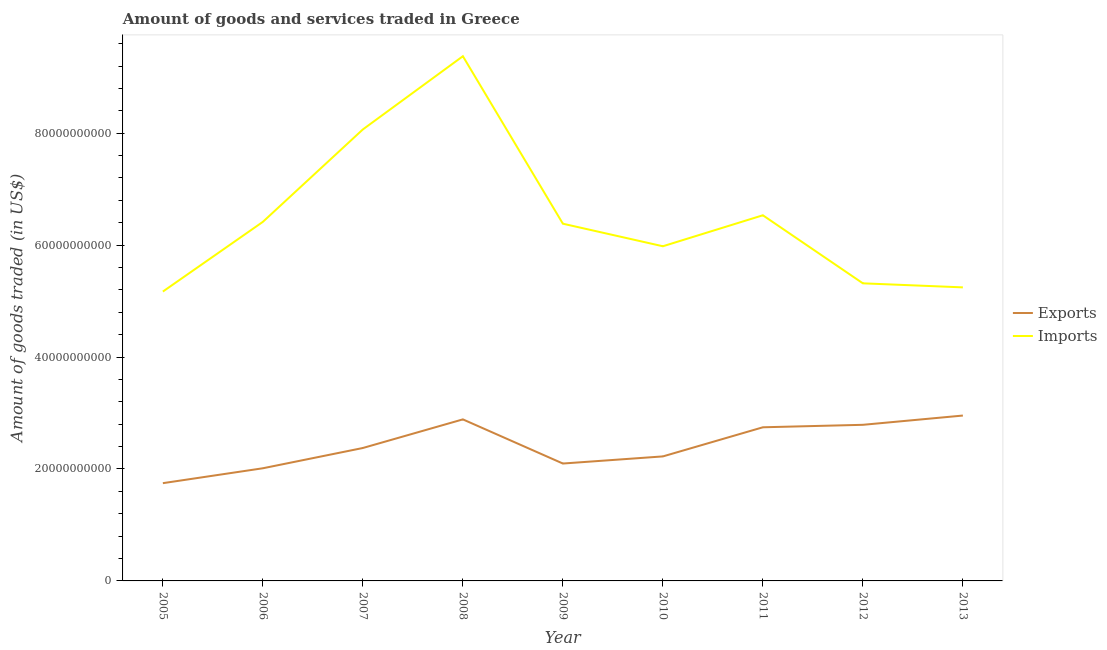How many different coloured lines are there?
Your response must be concise. 2. Does the line corresponding to amount of goods exported intersect with the line corresponding to amount of goods imported?
Provide a short and direct response. No. What is the amount of goods exported in 2006?
Keep it short and to the point. 2.01e+1. Across all years, what is the maximum amount of goods imported?
Provide a succinct answer. 9.38e+1. Across all years, what is the minimum amount of goods imported?
Provide a short and direct response. 5.17e+1. In which year was the amount of goods imported maximum?
Your answer should be compact. 2008. In which year was the amount of goods imported minimum?
Offer a terse response. 2005. What is the total amount of goods exported in the graph?
Your answer should be compact. 2.18e+11. What is the difference between the amount of goods imported in 2009 and that in 2010?
Provide a short and direct response. 4.03e+09. What is the difference between the amount of goods imported in 2006 and the amount of goods exported in 2005?
Make the answer very short. 4.67e+1. What is the average amount of goods exported per year?
Your answer should be very brief. 2.43e+1. In the year 2011, what is the difference between the amount of goods imported and amount of goods exported?
Your answer should be very brief. 3.79e+1. In how many years, is the amount of goods imported greater than 60000000000 US$?
Your answer should be very brief. 5. What is the ratio of the amount of goods imported in 2006 to that in 2009?
Your answer should be compact. 1.01. Is the amount of goods exported in 2011 less than that in 2012?
Give a very brief answer. Yes. What is the difference between the highest and the second highest amount of goods imported?
Your answer should be very brief. 1.31e+1. What is the difference between the highest and the lowest amount of goods imported?
Provide a succinct answer. 4.21e+1. In how many years, is the amount of goods imported greater than the average amount of goods imported taken over all years?
Offer a terse response. 3. Is the sum of the amount of goods imported in 2005 and 2010 greater than the maximum amount of goods exported across all years?
Ensure brevity in your answer.  Yes. Is the amount of goods imported strictly greater than the amount of goods exported over the years?
Offer a terse response. Yes. Is the amount of goods exported strictly less than the amount of goods imported over the years?
Your answer should be compact. Yes. How many lines are there?
Provide a succinct answer. 2. What is the difference between two consecutive major ticks on the Y-axis?
Offer a very short reply. 2.00e+1. Does the graph contain any zero values?
Make the answer very short. No. Does the graph contain grids?
Offer a very short reply. No. What is the title of the graph?
Provide a short and direct response. Amount of goods and services traded in Greece. What is the label or title of the Y-axis?
Provide a succinct answer. Amount of goods traded (in US$). What is the Amount of goods traded (in US$) in Exports in 2005?
Provide a succinct answer. 1.75e+1. What is the Amount of goods traded (in US$) in Imports in 2005?
Offer a terse response. 5.17e+1. What is the Amount of goods traded (in US$) of Exports in 2006?
Keep it short and to the point. 2.01e+1. What is the Amount of goods traded (in US$) in Imports in 2006?
Ensure brevity in your answer.  6.42e+1. What is the Amount of goods traded (in US$) of Exports in 2007?
Your answer should be compact. 2.38e+1. What is the Amount of goods traded (in US$) of Imports in 2007?
Offer a very short reply. 8.07e+1. What is the Amount of goods traded (in US$) in Exports in 2008?
Your answer should be very brief. 2.89e+1. What is the Amount of goods traded (in US$) in Imports in 2008?
Ensure brevity in your answer.  9.38e+1. What is the Amount of goods traded (in US$) in Exports in 2009?
Keep it short and to the point. 2.10e+1. What is the Amount of goods traded (in US$) in Imports in 2009?
Your response must be concise. 6.38e+1. What is the Amount of goods traded (in US$) of Exports in 2010?
Make the answer very short. 2.22e+1. What is the Amount of goods traded (in US$) of Imports in 2010?
Your answer should be compact. 5.98e+1. What is the Amount of goods traded (in US$) of Exports in 2011?
Provide a short and direct response. 2.75e+1. What is the Amount of goods traded (in US$) of Imports in 2011?
Give a very brief answer. 6.53e+1. What is the Amount of goods traded (in US$) of Exports in 2012?
Your answer should be very brief. 2.79e+1. What is the Amount of goods traded (in US$) in Imports in 2012?
Your response must be concise. 5.32e+1. What is the Amount of goods traded (in US$) in Exports in 2013?
Provide a succinct answer. 2.96e+1. What is the Amount of goods traded (in US$) in Imports in 2013?
Ensure brevity in your answer.  5.25e+1. Across all years, what is the maximum Amount of goods traded (in US$) of Exports?
Make the answer very short. 2.96e+1. Across all years, what is the maximum Amount of goods traded (in US$) in Imports?
Offer a very short reply. 9.38e+1. Across all years, what is the minimum Amount of goods traded (in US$) of Exports?
Your response must be concise. 1.75e+1. Across all years, what is the minimum Amount of goods traded (in US$) of Imports?
Make the answer very short. 5.17e+1. What is the total Amount of goods traded (in US$) of Exports in the graph?
Make the answer very short. 2.18e+11. What is the total Amount of goods traded (in US$) of Imports in the graph?
Make the answer very short. 5.85e+11. What is the difference between the Amount of goods traded (in US$) of Exports in 2005 and that in 2006?
Ensure brevity in your answer.  -2.66e+09. What is the difference between the Amount of goods traded (in US$) in Imports in 2005 and that in 2006?
Make the answer very short. -1.25e+1. What is the difference between the Amount of goods traded (in US$) of Exports in 2005 and that in 2007?
Make the answer very short. -6.28e+09. What is the difference between the Amount of goods traded (in US$) of Imports in 2005 and that in 2007?
Your answer should be very brief. -2.90e+1. What is the difference between the Amount of goods traded (in US$) of Exports in 2005 and that in 2008?
Give a very brief answer. -1.14e+1. What is the difference between the Amount of goods traded (in US$) in Imports in 2005 and that in 2008?
Your answer should be very brief. -4.21e+1. What is the difference between the Amount of goods traded (in US$) of Exports in 2005 and that in 2009?
Give a very brief answer. -3.51e+09. What is the difference between the Amount of goods traded (in US$) of Imports in 2005 and that in 2009?
Your answer should be very brief. -1.21e+1. What is the difference between the Amount of goods traded (in US$) in Exports in 2005 and that in 2010?
Ensure brevity in your answer.  -4.78e+09. What is the difference between the Amount of goods traded (in US$) in Imports in 2005 and that in 2010?
Offer a terse response. -8.10e+09. What is the difference between the Amount of goods traded (in US$) in Exports in 2005 and that in 2011?
Make the answer very short. -9.98e+09. What is the difference between the Amount of goods traded (in US$) of Imports in 2005 and that in 2011?
Your answer should be compact. -1.36e+1. What is the difference between the Amount of goods traded (in US$) in Exports in 2005 and that in 2012?
Your response must be concise. -1.04e+1. What is the difference between the Amount of goods traded (in US$) in Imports in 2005 and that in 2012?
Provide a short and direct response. -1.47e+09. What is the difference between the Amount of goods traded (in US$) in Exports in 2005 and that in 2013?
Keep it short and to the point. -1.21e+1. What is the difference between the Amount of goods traded (in US$) of Imports in 2005 and that in 2013?
Your answer should be compact. -7.50e+08. What is the difference between the Amount of goods traded (in US$) of Exports in 2006 and that in 2007?
Keep it short and to the point. -3.62e+09. What is the difference between the Amount of goods traded (in US$) in Imports in 2006 and that in 2007?
Make the answer very short. -1.65e+1. What is the difference between the Amount of goods traded (in US$) in Exports in 2006 and that in 2008?
Make the answer very short. -8.74e+09. What is the difference between the Amount of goods traded (in US$) of Imports in 2006 and that in 2008?
Provide a short and direct response. -2.96e+1. What is the difference between the Amount of goods traded (in US$) of Exports in 2006 and that in 2009?
Make the answer very short. -8.46e+08. What is the difference between the Amount of goods traded (in US$) in Imports in 2006 and that in 2009?
Offer a terse response. 3.30e+08. What is the difference between the Amount of goods traded (in US$) of Exports in 2006 and that in 2010?
Keep it short and to the point. -2.12e+09. What is the difference between the Amount of goods traded (in US$) in Imports in 2006 and that in 2010?
Your answer should be very brief. 4.36e+09. What is the difference between the Amount of goods traded (in US$) in Exports in 2006 and that in 2011?
Make the answer very short. -7.32e+09. What is the difference between the Amount of goods traded (in US$) of Imports in 2006 and that in 2011?
Offer a terse response. -1.17e+09. What is the difference between the Amount of goods traded (in US$) of Exports in 2006 and that in 2012?
Your response must be concise. -7.76e+09. What is the difference between the Amount of goods traded (in US$) in Imports in 2006 and that in 2012?
Your response must be concise. 1.10e+1. What is the difference between the Amount of goods traded (in US$) of Exports in 2006 and that in 2013?
Keep it short and to the point. -9.42e+09. What is the difference between the Amount of goods traded (in US$) of Imports in 2006 and that in 2013?
Offer a terse response. 1.17e+1. What is the difference between the Amount of goods traded (in US$) in Exports in 2007 and that in 2008?
Offer a terse response. -5.11e+09. What is the difference between the Amount of goods traded (in US$) of Imports in 2007 and that in 2008?
Provide a short and direct response. -1.31e+1. What is the difference between the Amount of goods traded (in US$) of Exports in 2007 and that in 2009?
Ensure brevity in your answer.  2.78e+09. What is the difference between the Amount of goods traded (in US$) in Imports in 2007 and that in 2009?
Your answer should be compact. 1.68e+1. What is the difference between the Amount of goods traded (in US$) in Exports in 2007 and that in 2010?
Ensure brevity in your answer.  1.50e+09. What is the difference between the Amount of goods traded (in US$) in Imports in 2007 and that in 2010?
Make the answer very short. 2.09e+1. What is the difference between the Amount of goods traded (in US$) in Exports in 2007 and that in 2011?
Your response must be concise. -3.70e+09. What is the difference between the Amount of goods traded (in US$) in Imports in 2007 and that in 2011?
Ensure brevity in your answer.  1.53e+1. What is the difference between the Amount of goods traded (in US$) of Exports in 2007 and that in 2012?
Make the answer very short. -4.14e+09. What is the difference between the Amount of goods traded (in US$) of Imports in 2007 and that in 2012?
Make the answer very short. 2.75e+1. What is the difference between the Amount of goods traded (in US$) in Exports in 2007 and that in 2013?
Keep it short and to the point. -5.80e+09. What is the difference between the Amount of goods traded (in US$) in Imports in 2007 and that in 2013?
Offer a very short reply. 2.82e+1. What is the difference between the Amount of goods traded (in US$) of Exports in 2008 and that in 2009?
Provide a succinct answer. 7.89e+09. What is the difference between the Amount of goods traded (in US$) in Imports in 2008 and that in 2009?
Your answer should be compact. 2.99e+1. What is the difference between the Amount of goods traded (in US$) in Exports in 2008 and that in 2010?
Give a very brief answer. 6.62e+09. What is the difference between the Amount of goods traded (in US$) in Imports in 2008 and that in 2010?
Your answer should be compact. 3.40e+1. What is the difference between the Amount of goods traded (in US$) in Exports in 2008 and that in 2011?
Offer a very short reply. 1.41e+09. What is the difference between the Amount of goods traded (in US$) of Imports in 2008 and that in 2011?
Provide a short and direct response. 2.84e+1. What is the difference between the Amount of goods traded (in US$) of Exports in 2008 and that in 2012?
Provide a short and direct response. 9.71e+08. What is the difference between the Amount of goods traded (in US$) of Imports in 2008 and that in 2012?
Give a very brief answer. 4.06e+1. What is the difference between the Amount of goods traded (in US$) of Exports in 2008 and that in 2013?
Provide a short and direct response. -6.85e+08. What is the difference between the Amount of goods traded (in US$) of Imports in 2008 and that in 2013?
Make the answer very short. 4.13e+1. What is the difference between the Amount of goods traded (in US$) of Exports in 2009 and that in 2010?
Your answer should be compact. -1.27e+09. What is the difference between the Amount of goods traded (in US$) in Imports in 2009 and that in 2010?
Your answer should be very brief. 4.03e+09. What is the difference between the Amount of goods traded (in US$) in Exports in 2009 and that in 2011?
Provide a succinct answer. -6.48e+09. What is the difference between the Amount of goods traded (in US$) in Imports in 2009 and that in 2011?
Keep it short and to the point. -1.50e+09. What is the difference between the Amount of goods traded (in US$) of Exports in 2009 and that in 2012?
Offer a terse response. -6.92e+09. What is the difference between the Amount of goods traded (in US$) of Imports in 2009 and that in 2012?
Your answer should be compact. 1.07e+1. What is the difference between the Amount of goods traded (in US$) of Exports in 2009 and that in 2013?
Your answer should be compact. -8.57e+09. What is the difference between the Amount of goods traded (in US$) in Imports in 2009 and that in 2013?
Make the answer very short. 1.14e+1. What is the difference between the Amount of goods traded (in US$) of Exports in 2010 and that in 2011?
Offer a very short reply. -5.20e+09. What is the difference between the Amount of goods traded (in US$) in Imports in 2010 and that in 2011?
Give a very brief answer. -5.54e+09. What is the difference between the Amount of goods traded (in US$) in Exports in 2010 and that in 2012?
Your answer should be very brief. -5.65e+09. What is the difference between the Amount of goods traded (in US$) in Imports in 2010 and that in 2012?
Your response must be concise. 6.63e+09. What is the difference between the Amount of goods traded (in US$) of Exports in 2010 and that in 2013?
Make the answer very short. -7.30e+09. What is the difference between the Amount of goods traded (in US$) of Imports in 2010 and that in 2013?
Your answer should be very brief. 7.35e+09. What is the difference between the Amount of goods traded (in US$) of Exports in 2011 and that in 2012?
Make the answer very short. -4.41e+08. What is the difference between the Amount of goods traded (in US$) in Imports in 2011 and that in 2012?
Keep it short and to the point. 1.22e+1. What is the difference between the Amount of goods traded (in US$) in Exports in 2011 and that in 2013?
Offer a terse response. -2.10e+09. What is the difference between the Amount of goods traded (in US$) of Imports in 2011 and that in 2013?
Offer a very short reply. 1.29e+1. What is the difference between the Amount of goods traded (in US$) in Exports in 2012 and that in 2013?
Keep it short and to the point. -1.66e+09. What is the difference between the Amount of goods traded (in US$) in Imports in 2012 and that in 2013?
Provide a succinct answer. 7.21e+08. What is the difference between the Amount of goods traded (in US$) of Exports in 2005 and the Amount of goods traded (in US$) of Imports in 2006?
Your answer should be very brief. -4.67e+1. What is the difference between the Amount of goods traded (in US$) in Exports in 2005 and the Amount of goods traded (in US$) in Imports in 2007?
Offer a very short reply. -6.32e+1. What is the difference between the Amount of goods traded (in US$) in Exports in 2005 and the Amount of goods traded (in US$) in Imports in 2008?
Keep it short and to the point. -7.63e+1. What is the difference between the Amount of goods traded (in US$) in Exports in 2005 and the Amount of goods traded (in US$) in Imports in 2009?
Keep it short and to the point. -4.64e+1. What is the difference between the Amount of goods traded (in US$) in Exports in 2005 and the Amount of goods traded (in US$) in Imports in 2010?
Keep it short and to the point. -4.23e+1. What is the difference between the Amount of goods traded (in US$) in Exports in 2005 and the Amount of goods traded (in US$) in Imports in 2011?
Offer a very short reply. -4.79e+1. What is the difference between the Amount of goods traded (in US$) of Exports in 2005 and the Amount of goods traded (in US$) of Imports in 2012?
Provide a succinct answer. -3.57e+1. What is the difference between the Amount of goods traded (in US$) of Exports in 2005 and the Amount of goods traded (in US$) of Imports in 2013?
Make the answer very short. -3.50e+1. What is the difference between the Amount of goods traded (in US$) in Exports in 2006 and the Amount of goods traded (in US$) in Imports in 2007?
Ensure brevity in your answer.  -6.05e+1. What is the difference between the Amount of goods traded (in US$) in Exports in 2006 and the Amount of goods traded (in US$) in Imports in 2008?
Give a very brief answer. -7.36e+1. What is the difference between the Amount of goods traded (in US$) of Exports in 2006 and the Amount of goods traded (in US$) of Imports in 2009?
Your response must be concise. -4.37e+1. What is the difference between the Amount of goods traded (in US$) in Exports in 2006 and the Amount of goods traded (in US$) in Imports in 2010?
Your answer should be very brief. -3.97e+1. What is the difference between the Amount of goods traded (in US$) of Exports in 2006 and the Amount of goods traded (in US$) of Imports in 2011?
Provide a succinct answer. -4.52e+1. What is the difference between the Amount of goods traded (in US$) in Exports in 2006 and the Amount of goods traded (in US$) in Imports in 2012?
Provide a short and direct response. -3.30e+1. What is the difference between the Amount of goods traded (in US$) in Exports in 2006 and the Amount of goods traded (in US$) in Imports in 2013?
Give a very brief answer. -3.23e+1. What is the difference between the Amount of goods traded (in US$) in Exports in 2007 and the Amount of goods traded (in US$) in Imports in 2008?
Your response must be concise. -7.00e+1. What is the difference between the Amount of goods traded (in US$) in Exports in 2007 and the Amount of goods traded (in US$) in Imports in 2009?
Make the answer very short. -4.01e+1. What is the difference between the Amount of goods traded (in US$) in Exports in 2007 and the Amount of goods traded (in US$) in Imports in 2010?
Provide a short and direct response. -3.60e+1. What is the difference between the Amount of goods traded (in US$) in Exports in 2007 and the Amount of goods traded (in US$) in Imports in 2011?
Your response must be concise. -4.16e+1. What is the difference between the Amount of goods traded (in US$) in Exports in 2007 and the Amount of goods traded (in US$) in Imports in 2012?
Give a very brief answer. -2.94e+1. What is the difference between the Amount of goods traded (in US$) in Exports in 2007 and the Amount of goods traded (in US$) in Imports in 2013?
Provide a short and direct response. -2.87e+1. What is the difference between the Amount of goods traded (in US$) of Exports in 2008 and the Amount of goods traded (in US$) of Imports in 2009?
Your response must be concise. -3.50e+1. What is the difference between the Amount of goods traded (in US$) in Exports in 2008 and the Amount of goods traded (in US$) in Imports in 2010?
Your answer should be very brief. -3.09e+1. What is the difference between the Amount of goods traded (in US$) in Exports in 2008 and the Amount of goods traded (in US$) in Imports in 2011?
Provide a short and direct response. -3.65e+1. What is the difference between the Amount of goods traded (in US$) in Exports in 2008 and the Amount of goods traded (in US$) in Imports in 2012?
Ensure brevity in your answer.  -2.43e+1. What is the difference between the Amount of goods traded (in US$) in Exports in 2008 and the Amount of goods traded (in US$) in Imports in 2013?
Your response must be concise. -2.36e+1. What is the difference between the Amount of goods traded (in US$) of Exports in 2009 and the Amount of goods traded (in US$) of Imports in 2010?
Your response must be concise. -3.88e+1. What is the difference between the Amount of goods traded (in US$) of Exports in 2009 and the Amount of goods traded (in US$) of Imports in 2011?
Your answer should be very brief. -4.44e+1. What is the difference between the Amount of goods traded (in US$) of Exports in 2009 and the Amount of goods traded (in US$) of Imports in 2012?
Make the answer very short. -3.22e+1. What is the difference between the Amount of goods traded (in US$) of Exports in 2009 and the Amount of goods traded (in US$) of Imports in 2013?
Keep it short and to the point. -3.15e+1. What is the difference between the Amount of goods traded (in US$) in Exports in 2010 and the Amount of goods traded (in US$) in Imports in 2011?
Your response must be concise. -4.31e+1. What is the difference between the Amount of goods traded (in US$) in Exports in 2010 and the Amount of goods traded (in US$) in Imports in 2012?
Keep it short and to the point. -3.09e+1. What is the difference between the Amount of goods traded (in US$) of Exports in 2010 and the Amount of goods traded (in US$) of Imports in 2013?
Make the answer very short. -3.02e+1. What is the difference between the Amount of goods traded (in US$) in Exports in 2011 and the Amount of goods traded (in US$) in Imports in 2012?
Your answer should be very brief. -2.57e+1. What is the difference between the Amount of goods traded (in US$) in Exports in 2011 and the Amount of goods traded (in US$) in Imports in 2013?
Your answer should be compact. -2.50e+1. What is the difference between the Amount of goods traded (in US$) of Exports in 2012 and the Amount of goods traded (in US$) of Imports in 2013?
Provide a succinct answer. -2.46e+1. What is the average Amount of goods traded (in US$) of Exports per year?
Your answer should be compact. 2.43e+1. What is the average Amount of goods traded (in US$) in Imports per year?
Your answer should be compact. 6.50e+1. In the year 2005, what is the difference between the Amount of goods traded (in US$) in Exports and Amount of goods traded (in US$) in Imports?
Give a very brief answer. -3.42e+1. In the year 2006, what is the difference between the Amount of goods traded (in US$) of Exports and Amount of goods traded (in US$) of Imports?
Offer a very short reply. -4.40e+1. In the year 2007, what is the difference between the Amount of goods traded (in US$) in Exports and Amount of goods traded (in US$) in Imports?
Provide a succinct answer. -5.69e+1. In the year 2008, what is the difference between the Amount of goods traded (in US$) of Exports and Amount of goods traded (in US$) of Imports?
Provide a short and direct response. -6.49e+1. In the year 2009, what is the difference between the Amount of goods traded (in US$) of Exports and Amount of goods traded (in US$) of Imports?
Make the answer very short. -4.29e+1. In the year 2010, what is the difference between the Amount of goods traded (in US$) of Exports and Amount of goods traded (in US$) of Imports?
Offer a very short reply. -3.76e+1. In the year 2011, what is the difference between the Amount of goods traded (in US$) of Exports and Amount of goods traded (in US$) of Imports?
Your answer should be compact. -3.79e+1. In the year 2012, what is the difference between the Amount of goods traded (in US$) of Exports and Amount of goods traded (in US$) of Imports?
Give a very brief answer. -2.53e+1. In the year 2013, what is the difference between the Amount of goods traded (in US$) of Exports and Amount of goods traded (in US$) of Imports?
Offer a terse response. -2.29e+1. What is the ratio of the Amount of goods traded (in US$) of Exports in 2005 to that in 2006?
Give a very brief answer. 0.87. What is the ratio of the Amount of goods traded (in US$) of Imports in 2005 to that in 2006?
Your response must be concise. 0.81. What is the ratio of the Amount of goods traded (in US$) of Exports in 2005 to that in 2007?
Give a very brief answer. 0.74. What is the ratio of the Amount of goods traded (in US$) in Imports in 2005 to that in 2007?
Provide a succinct answer. 0.64. What is the ratio of the Amount of goods traded (in US$) of Exports in 2005 to that in 2008?
Offer a terse response. 0.61. What is the ratio of the Amount of goods traded (in US$) of Imports in 2005 to that in 2008?
Give a very brief answer. 0.55. What is the ratio of the Amount of goods traded (in US$) in Exports in 2005 to that in 2009?
Offer a very short reply. 0.83. What is the ratio of the Amount of goods traded (in US$) in Imports in 2005 to that in 2009?
Ensure brevity in your answer.  0.81. What is the ratio of the Amount of goods traded (in US$) in Exports in 2005 to that in 2010?
Give a very brief answer. 0.79. What is the ratio of the Amount of goods traded (in US$) in Imports in 2005 to that in 2010?
Give a very brief answer. 0.86. What is the ratio of the Amount of goods traded (in US$) of Exports in 2005 to that in 2011?
Your answer should be compact. 0.64. What is the ratio of the Amount of goods traded (in US$) of Imports in 2005 to that in 2011?
Offer a terse response. 0.79. What is the ratio of the Amount of goods traded (in US$) of Exports in 2005 to that in 2012?
Give a very brief answer. 0.63. What is the ratio of the Amount of goods traded (in US$) in Imports in 2005 to that in 2012?
Offer a terse response. 0.97. What is the ratio of the Amount of goods traded (in US$) in Exports in 2005 to that in 2013?
Give a very brief answer. 0.59. What is the ratio of the Amount of goods traded (in US$) in Imports in 2005 to that in 2013?
Provide a short and direct response. 0.99. What is the ratio of the Amount of goods traded (in US$) of Exports in 2006 to that in 2007?
Give a very brief answer. 0.85. What is the ratio of the Amount of goods traded (in US$) of Imports in 2006 to that in 2007?
Your answer should be compact. 0.8. What is the ratio of the Amount of goods traded (in US$) in Exports in 2006 to that in 2008?
Offer a terse response. 0.7. What is the ratio of the Amount of goods traded (in US$) of Imports in 2006 to that in 2008?
Your answer should be compact. 0.68. What is the ratio of the Amount of goods traded (in US$) in Exports in 2006 to that in 2009?
Your answer should be very brief. 0.96. What is the ratio of the Amount of goods traded (in US$) of Imports in 2006 to that in 2009?
Keep it short and to the point. 1.01. What is the ratio of the Amount of goods traded (in US$) in Exports in 2006 to that in 2010?
Offer a very short reply. 0.9. What is the ratio of the Amount of goods traded (in US$) in Imports in 2006 to that in 2010?
Your answer should be compact. 1.07. What is the ratio of the Amount of goods traded (in US$) in Exports in 2006 to that in 2011?
Ensure brevity in your answer.  0.73. What is the ratio of the Amount of goods traded (in US$) of Exports in 2006 to that in 2012?
Keep it short and to the point. 0.72. What is the ratio of the Amount of goods traded (in US$) of Imports in 2006 to that in 2012?
Ensure brevity in your answer.  1.21. What is the ratio of the Amount of goods traded (in US$) of Exports in 2006 to that in 2013?
Provide a short and direct response. 0.68. What is the ratio of the Amount of goods traded (in US$) of Imports in 2006 to that in 2013?
Your answer should be compact. 1.22. What is the ratio of the Amount of goods traded (in US$) in Exports in 2007 to that in 2008?
Offer a terse response. 0.82. What is the ratio of the Amount of goods traded (in US$) of Imports in 2007 to that in 2008?
Provide a short and direct response. 0.86. What is the ratio of the Amount of goods traded (in US$) in Exports in 2007 to that in 2009?
Give a very brief answer. 1.13. What is the ratio of the Amount of goods traded (in US$) of Imports in 2007 to that in 2009?
Your response must be concise. 1.26. What is the ratio of the Amount of goods traded (in US$) in Exports in 2007 to that in 2010?
Offer a very short reply. 1.07. What is the ratio of the Amount of goods traded (in US$) in Imports in 2007 to that in 2010?
Offer a terse response. 1.35. What is the ratio of the Amount of goods traded (in US$) of Exports in 2007 to that in 2011?
Give a very brief answer. 0.87. What is the ratio of the Amount of goods traded (in US$) in Imports in 2007 to that in 2011?
Provide a succinct answer. 1.23. What is the ratio of the Amount of goods traded (in US$) of Exports in 2007 to that in 2012?
Your response must be concise. 0.85. What is the ratio of the Amount of goods traded (in US$) in Imports in 2007 to that in 2012?
Keep it short and to the point. 1.52. What is the ratio of the Amount of goods traded (in US$) in Exports in 2007 to that in 2013?
Offer a terse response. 0.8. What is the ratio of the Amount of goods traded (in US$) in Imports in 2007 to that in 2013?
Provide a succinct answer. 1.54. What is the ratio of the Amount of goods traded (in US$) in Exports in 2008 to that in 2009?
Give a very brief answer. 1.38. What is the ratio of the Amount of goods traded (in US$) of Imports in 2008 to that in 2009?
Provide a short and direct response. 1.47. What is the ratio of the Amount of goods traded (in US$) of Exports in 2008 to that in 2010?
Your answer should be very brief. 1.3. What is the ratio of the Amount of goods traded (in US$) in Imports in 2008 to that in 2010?
Keep it short and to the point. 1.57. What is the ratio of the Amount of goods traded (in US$) of Exports in 2008 to that in 2011?
Offer a terse response. 1.05. What is the ratio of the Amount of goods traded (in US$) of Imports in 2008 to that in 2011?
Offer a terse response. 1.44. What is the ratio of the Amount of goods traded (in US$) of Exports in 2008 to that in 2012?
Your response must be concise. 1.03. What is the ratio of the Amount of goods traded (in US$) of Imports in 2008 to that in 2012?
Provide a succinct answer. 1.76. What is the ratio of the Amount of goods traded (in US$) in Exports in 2008 to that in 2013?
Offer a very short reply. 0.98. What is the ratio of the Amount of goods traded (in US$) in Imports in 2008 to that in 2013?
Provide a short and direct response. 1.79. What is the ratio of the Amount of goods traded (in US$) of Exports in 2009 to that in 2010?
Offer a very short reply. 0.94. What is the ratio of the Amount of goods traded (in US$) in Imports in 2009 to that in 2010?
Your answer should be compact. 1.07. What is the ratio of the Amount of goods traded (in US$) of Exports in 2009 to that in 2011?
Give a very brief answer. 0.76. What is the ratio of the Amount of goods traded (in US$) in Imports in 2009 to that in 2011?
Provide a short and direct response. 0.98. What is the ratio of the Amount of goods traded (in US$) in Exports in 2009 to that in 2012?
Provide a short and direct response. 0.75. What is the ratio of the Amount of goods traded (in US$) in Imports in 2009 to that in 2012?
Make the answer very short. 1.2. What is the ratio of the Amount of goods traded (in US$) of Exports in 2009 to that in 2013?
Offer a terse response. 0.71. What is the ratio of the Amount of goods traded (in US$) in Imports in 2009 to that in 2013?
Offer a very short reply. 1.22. What is the ratio of the Amount of goods traded (in US$) of Exports in 2010 to that in 2011?
Your response must be concise. 0.81. What is the ratio of the Amount of goods traded (in US$) of Imports in 2010 to that in 2011?
Offer a terse response. 0.92. What is the ratio of the Amount of goods traded (in US$) of Exports in 2010 to that in 2012?
Provide a short and direct response. 0.8. What is the ratio of the Amount of goods traded (in US$) in Imports in 2010 to that in 2012?
Ensure brevity in your answer.  1.12. What is the ratio of the Amount of goods traded (in US$) of Exports in 2010 to that in 2013?
Keep it short and to the point. 0.75. What is the ratio of the Amount of goods traded (in US$) of Imports in 2010 to that in 2013?
Provide a succinct answer. 1.14. What is the ratio of the Amount of goods traded (in US$) of Exports in 2011 to that in 2012?
Your response must be concise. 0.98. What is the ratio of the Amount of goods traded (in US$) in Imports in 2011 to that in 2012?
Make the answer very short. 1.23. What is the ratio of the Amount of goods traded (in US$) in Exports in 2011 to that in 2013?
Your answer should be compact. 0.93. What is the ratio of the Amount of goods traded (in US$) of Imports in 2011 to that in 2013?
Keep it short and to the point. 1.25. What is the ratio of the Amount of goods traded (in US$) of Exports in 2012 to that in 2013?
Provide a short and direct response. 0.94. What is the ratio of the Amount of goods traded (in US$) in Imports in 2012 to that in 2013?
Provide a short and direct response. 1.01. What is the difference between the highest and the second highest Amount of goods traded (in US$) of Exports?
Keep it short and to the point. 6.85e+08. What is the difference between the highest and the second highest Amount of goods traded (in US$) in Imports?
Your answer should be very brief. 1.31e+1. What is the difference between the highest and the lowest Amount of goods traded (in US$) of Exports?
Keep it short and to the point. 1.21e+1. What is the difference between the highest and the lowest Amount of goods traded (in US$) in Imports?
Your response must be concise. 4.21e+1. 